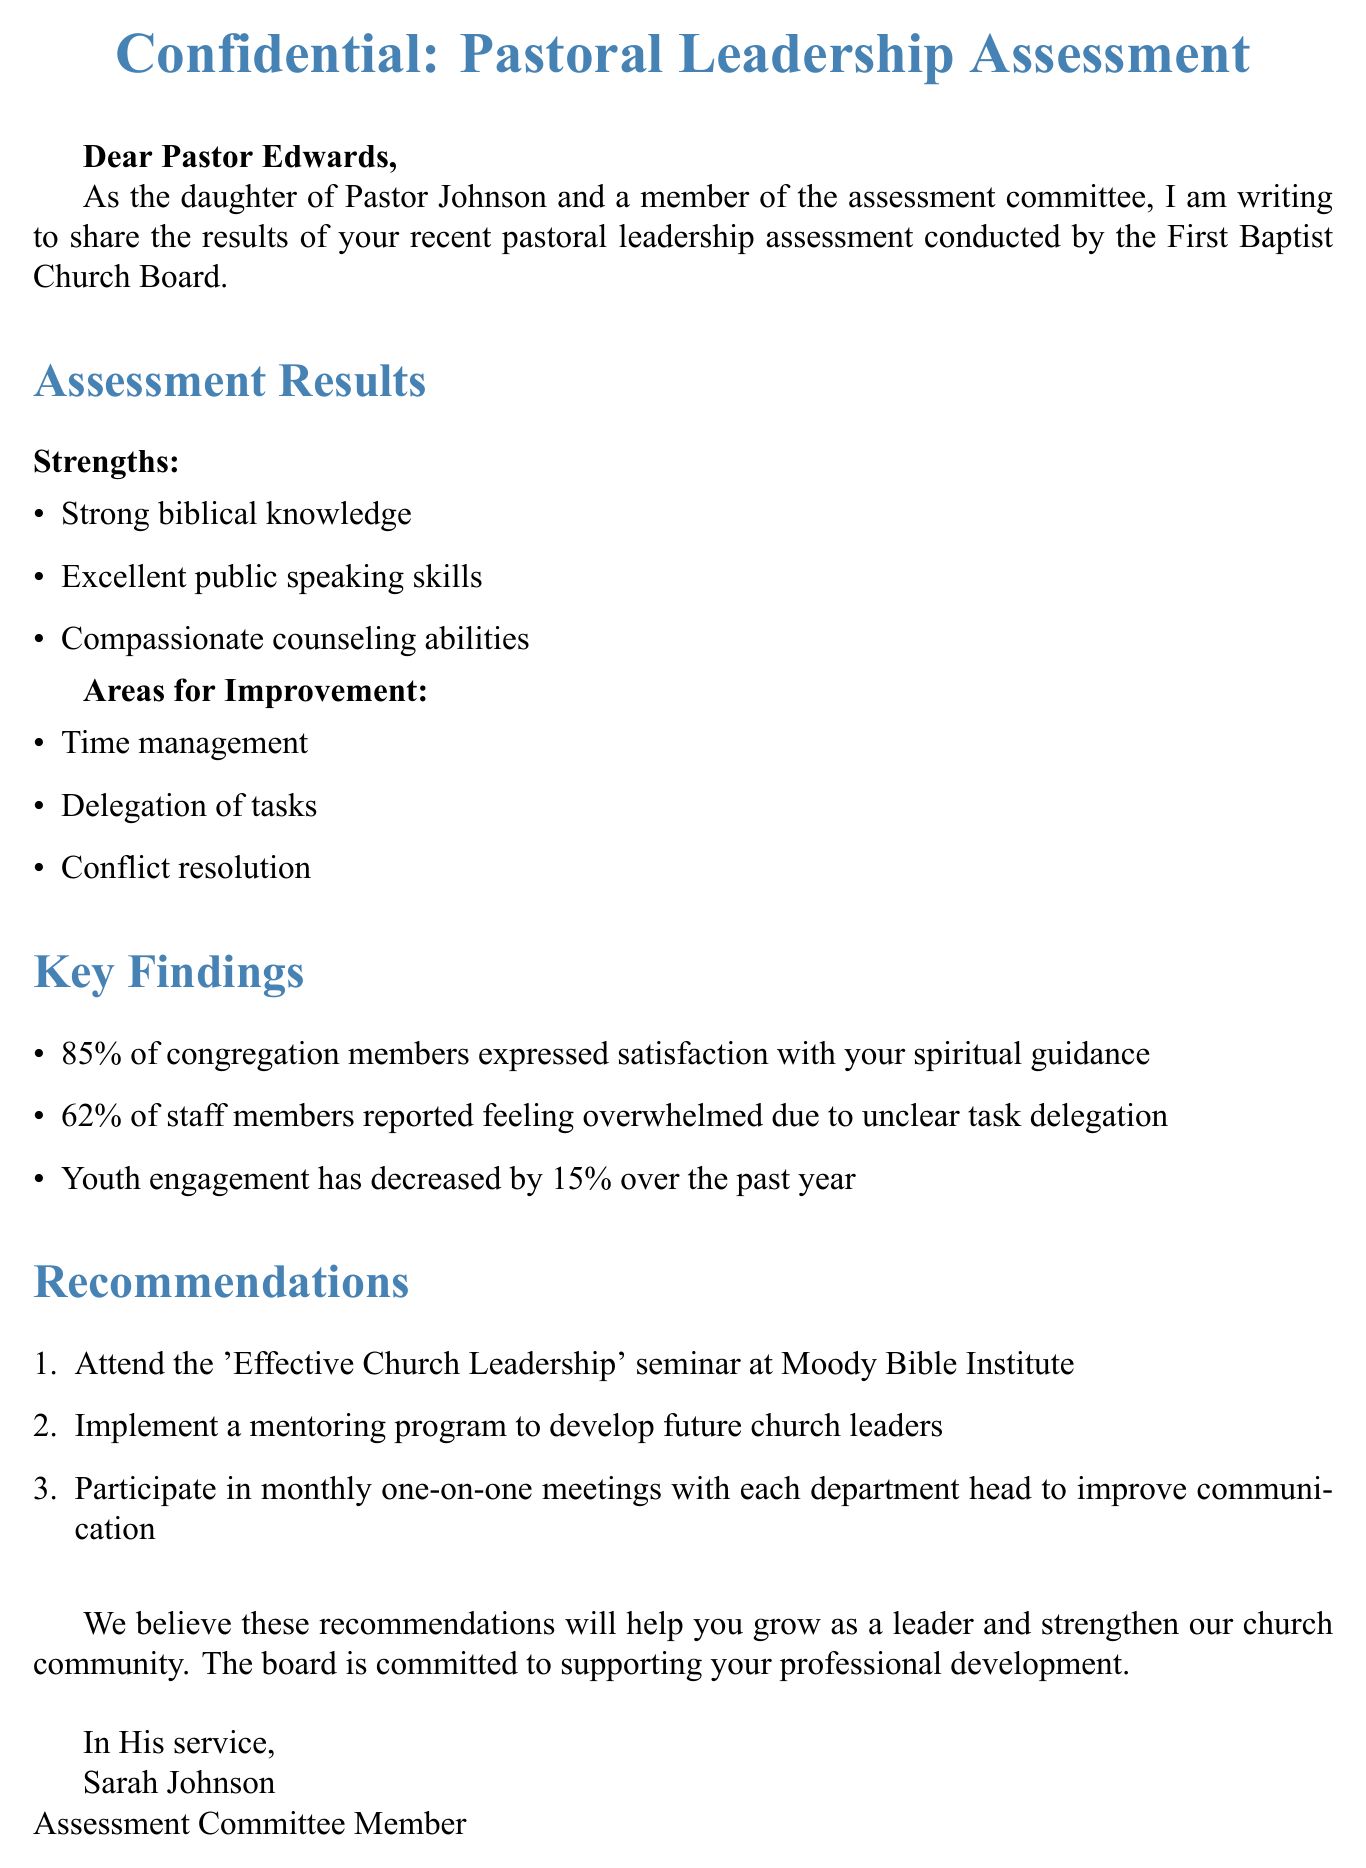What is the subject of the email? The subject of the email provides insight into the main focus of the document, which is the assessment results and recommendations.
Answer: Confidential: Pastoral Leadership Assessment Results and Recommendations Who is the sender of the email? The sender's name appears at the end of the email, providing information about their role in the assessment committee.
Answer: Sarah Johnson What percentage of congregation members expressed satisfaction? This statistic highlights the congregation's approval of Pastor Edwards' spiritual guidance, which is a key finding in the assessment.
Answer: 85% What is one area for improvement listed in the assessment? This question targets specific suggestions for Pastor Edwards to enhance his leadership skills as noted in the assessment results.
Answer: Time management What recommendation is made regarding leadership seminars? This recommendation suggests a professional development opportunity aimed at improving leadership skills, which is crucial for Pastor Edwards' growth.
Answer: Attend the 'Effective Church Leadership' seminar at Moody Bible Institute What percentage decrease in youth engagement was reported? This figure indicates a significant decline in youth involvement, which is vital information for understanding the church's community engagement.
Answer: 15% What type of program does the assessment recommend implementing? This question focuses on the suggestions for developing future leaders within the church, emphasizing succession planning.
Answer: Mentoring program Which congregation member's satisfaction is notably high? This information reveals positive feedback from congregation members about Pastor Edwards' pastoral care, indicating strengths in his approach.
Answer: Spiritual guidance How does the email conclude? The conclusion summarizes the support committed to Pastor Edwards for his professional development, providing encouragement.
Answer: The board is committed to supporting your professional development 